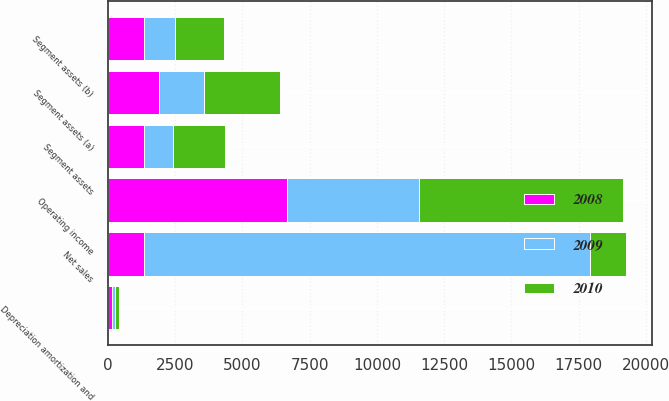Convert chart to OTSL. <chart><loc_0><loc_0><loc_500><loc_500><stacked_bar_chart><ecel><fcel>Net sales<fcel>Operating income<fcel>Depreciation amortization and<fcel>Segment assets (a)<fcel>Segment assets<fcel>Segment assets (b)<nl><fcel>2010<fcel>1352<fcel>7590<fcel>163<fcel>2809<fcel>1926<fcel>1829<nl><fcel>2008<fcel>1352<fcel>6658<fcel>146<fcel>1896<fcel>1352<fcel>1344<nl><fcel>2009<fcel>16552<fcel>4901<fcel>108<fcel>1693<fcel>1069<fcel>1139<nl></chart> 